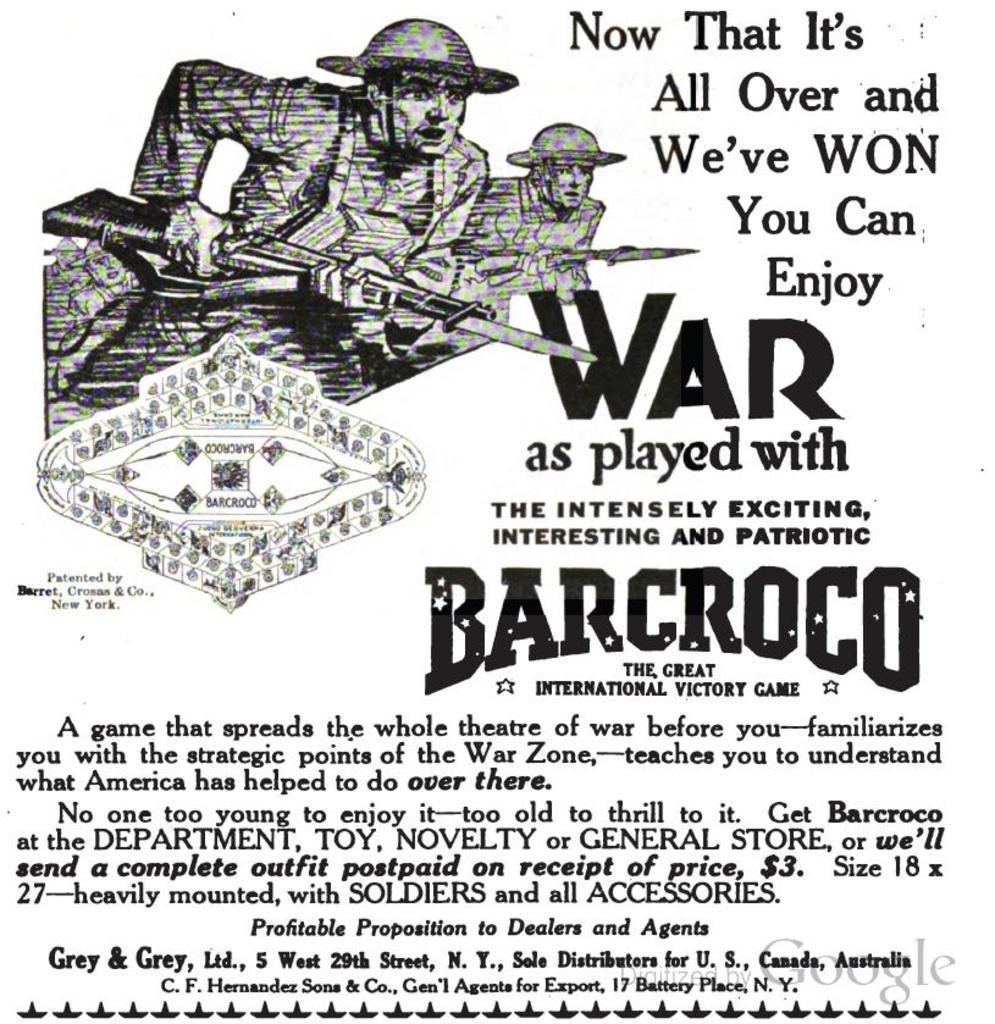What is present in the image? There is a paper in the image. What can be found on the paper? The paper contains text and images of persons. How many kittens are visible on the paper in the image? There are no kittens present on the paper in the image. What is the tax rate mentioned in the text on the paper? The provided facts do not mention any tax rate in the text on the paper. 